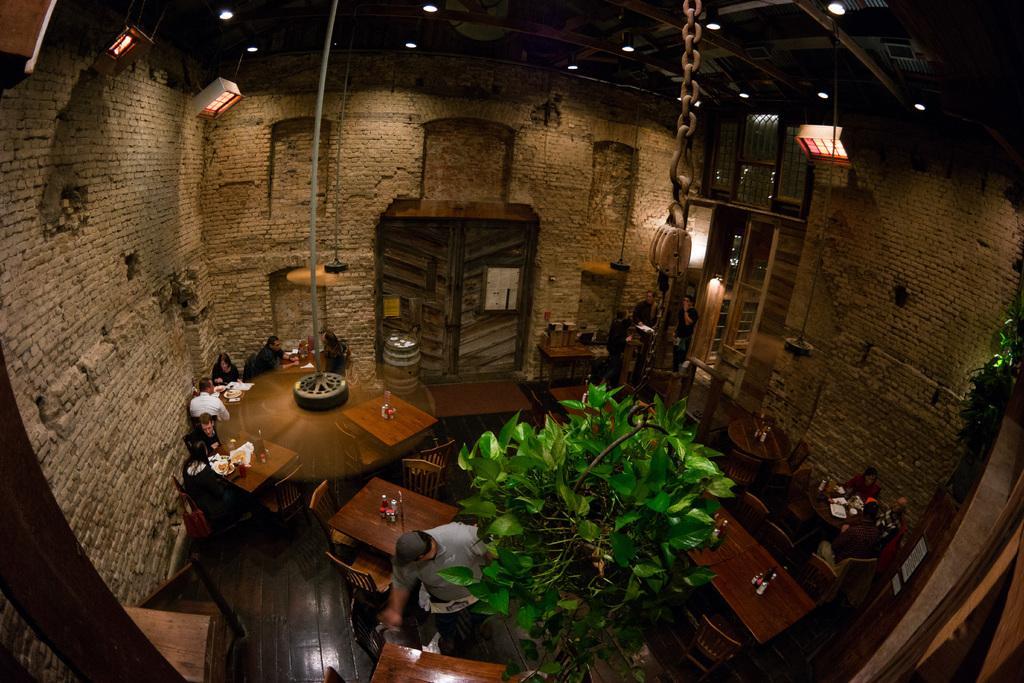In one or two sentences, can you explain what this image depicts? In this image, I can see a few people standing and few people sitting. These are the tables with the bottles and few other things on it. This looks like an iron chain with a hanger. This is a plant with the leaves. I can see a wooden barrel. These are the doors. At the top of the image, I can see the lights, which are attached to the ceiling. These look like the windows. I think this is the mirror. 